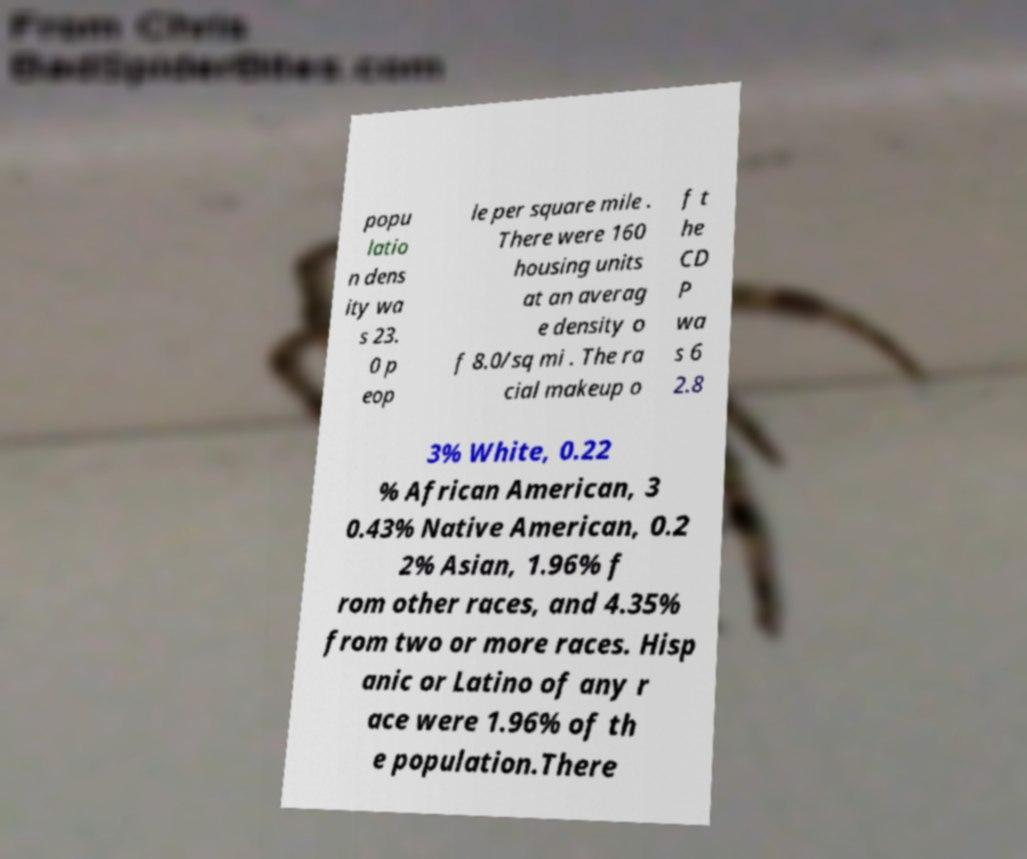Can you read and provide the text displayed in the image?This photo seems to have some interesting text. Can you extract and type it out for me? popu latio n dens ity wa s 23. 0 p eop le per square mile . There were 160 housing units at an averag e density o f 8.0/sq mi . The ra cial makeup o f t he CD P wa s 6 2.8 3% White, 0.22 % African American, 3 0.43% Native American, 0.2 2% Asian, 1.96% f rom other races, and 4.35% from two or more races. Hisp anic or Latino of any r ace were 1.96% of th e population.There 